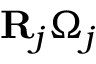Convert formula to latex. <formula><loc_0><loc_0><loc_500><loc_500>{ R } _ { j } \Omega _ { j }</formula> 